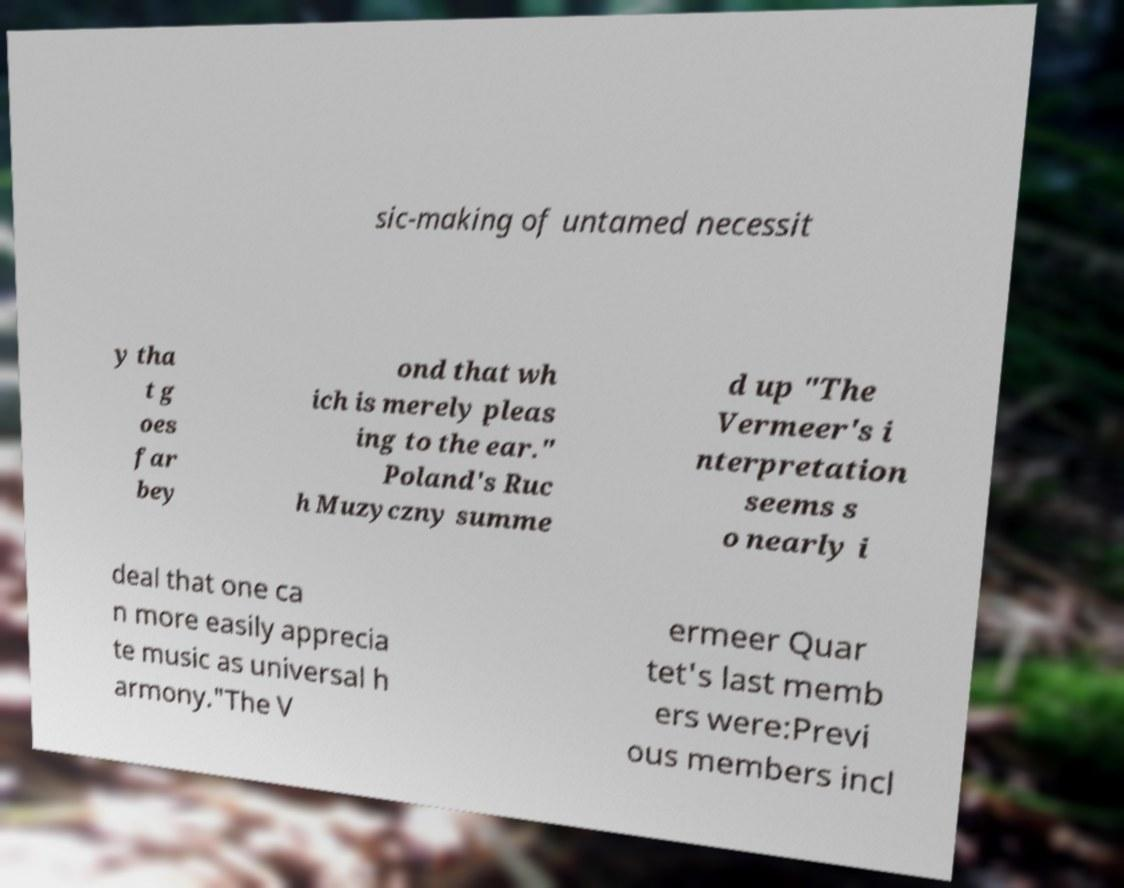I need the written content from this picture converted into text. Can you do that? sic-making of untamed necessit y tha t g oes far bey ond that wh ich is merely pleas ing to the ear." Poland's Ruc h Muzyczny summe d up "The Vermeer's i nterpretation seems s o nearly i deal that one ca n more easily apprecia te music as universal h armony."The V ermeer Quar tet's last memb ers were:Previ ous members incl 